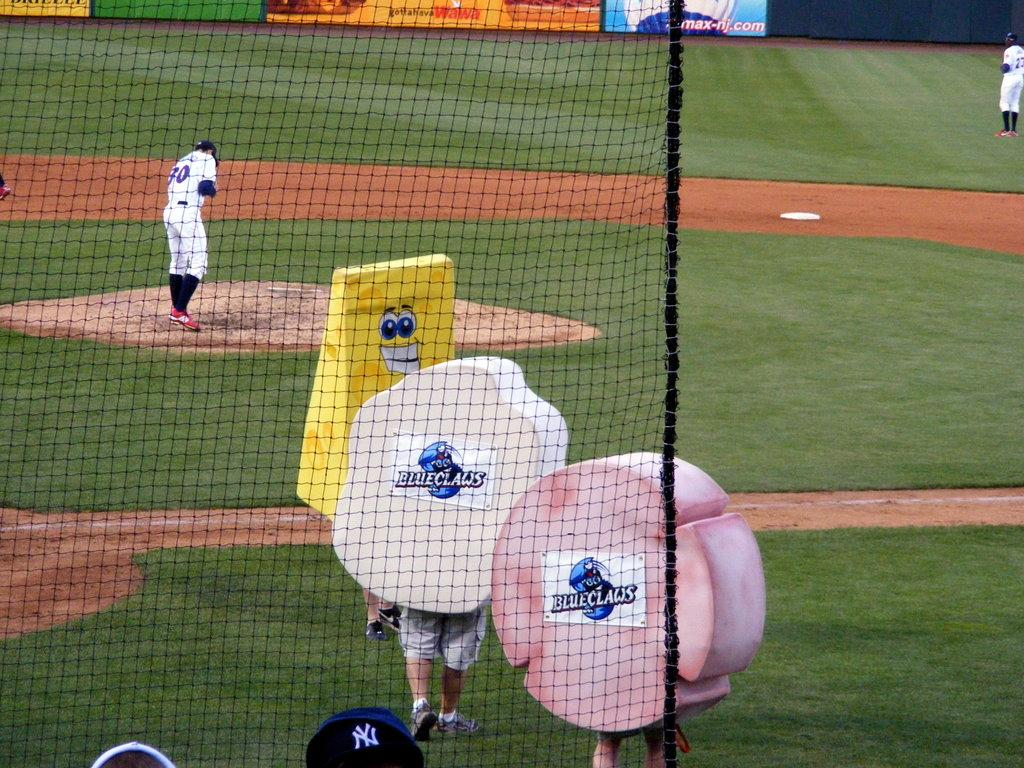Provide a one-sentence caption for the provided image. Blueclaw mascots walk onto the baseball field as the pitcher stands on the mound. 